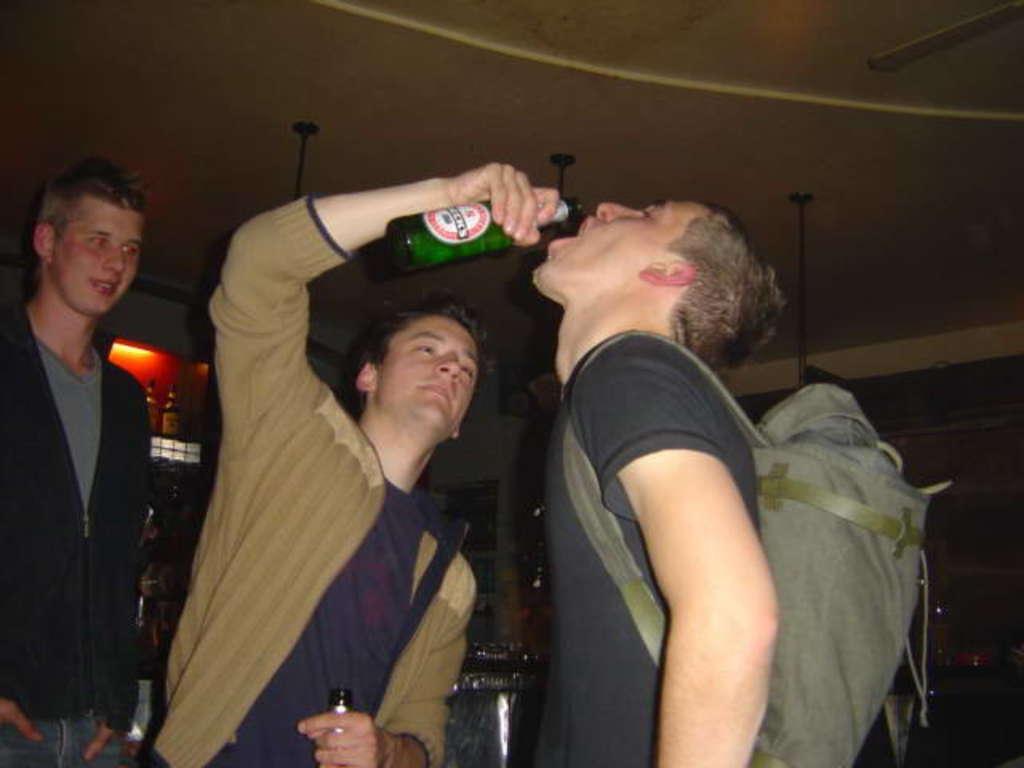Describe this image in one or two sentences. This image consists of three men. To the right, there is a man wearing black jacket is drinking a beer. At the top, there is a roof. In the middle, the man is wearing brown jacket. 